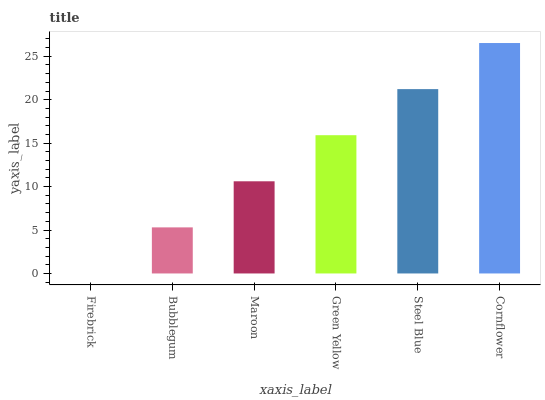Is Bubblegum the minimum?
Answer yes or no. No. Is Bubblegum the maximum?
Answer yes or no. No. Is Bubblegum greater than Firebrick?
Answer yes or no. Yes. Is Firebrick less than Bubblegum?
Answer yes or no. Yes. Is Firebrick greater than Bubblegum?
Answer yes or no. No. Is Bubblegum less than Firebrick?
Answer yes or no. No. Is Green Yellow the high median?
Answer yes or no. Yes. Is Maroon the low median?
Answer yes or no. Yes. Is Cornflower the high median?
Answer yes or no. No. Is Green Yellow the low median?
Answer yes or no. No. 